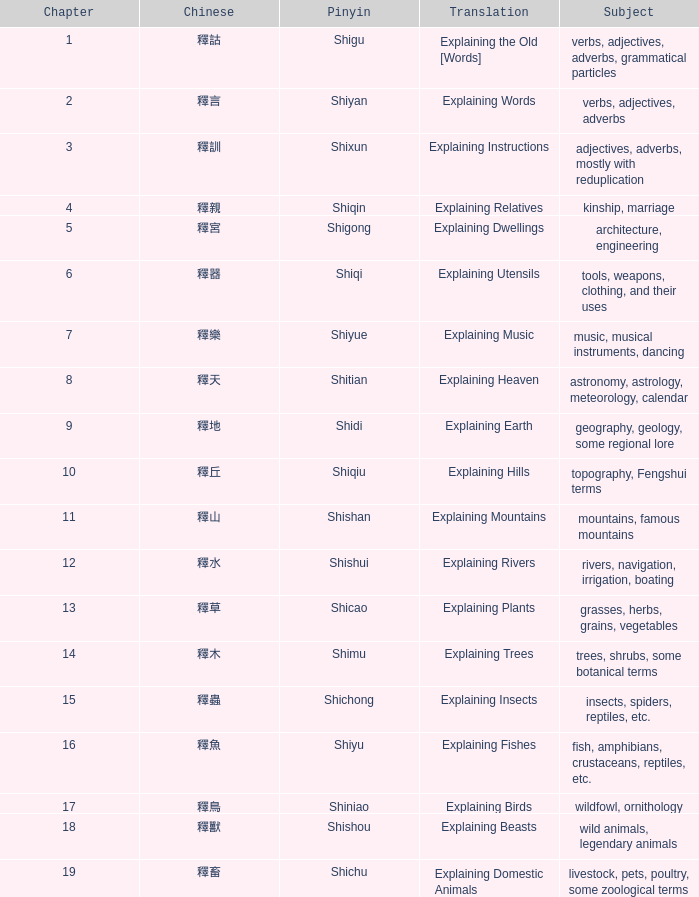Which is the highest chapter containing the chinese phrase "釋言"? 2.0. 